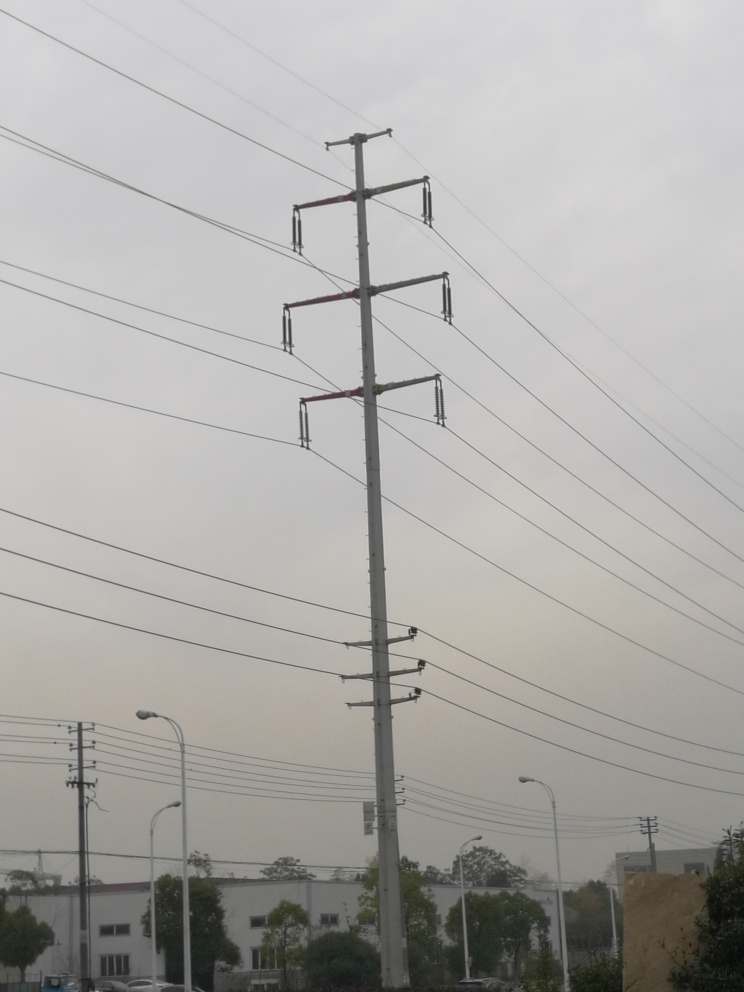Can you tell me about the structure in the middle of the image? Certainly, that is a high-voltage transmission tower, also known as an electricity pylon. It's part of the electrical grid designed to carry power over long distances. The particular design with the vertical configuration indicates that it carries multiple circuits. 